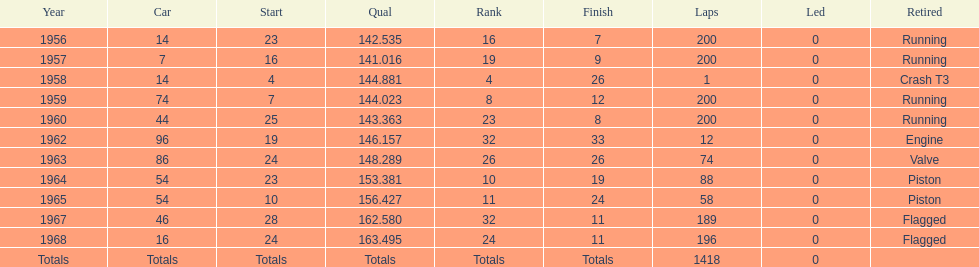How many times was bob veith ranked higher than 10 at an indy 500? 2. 